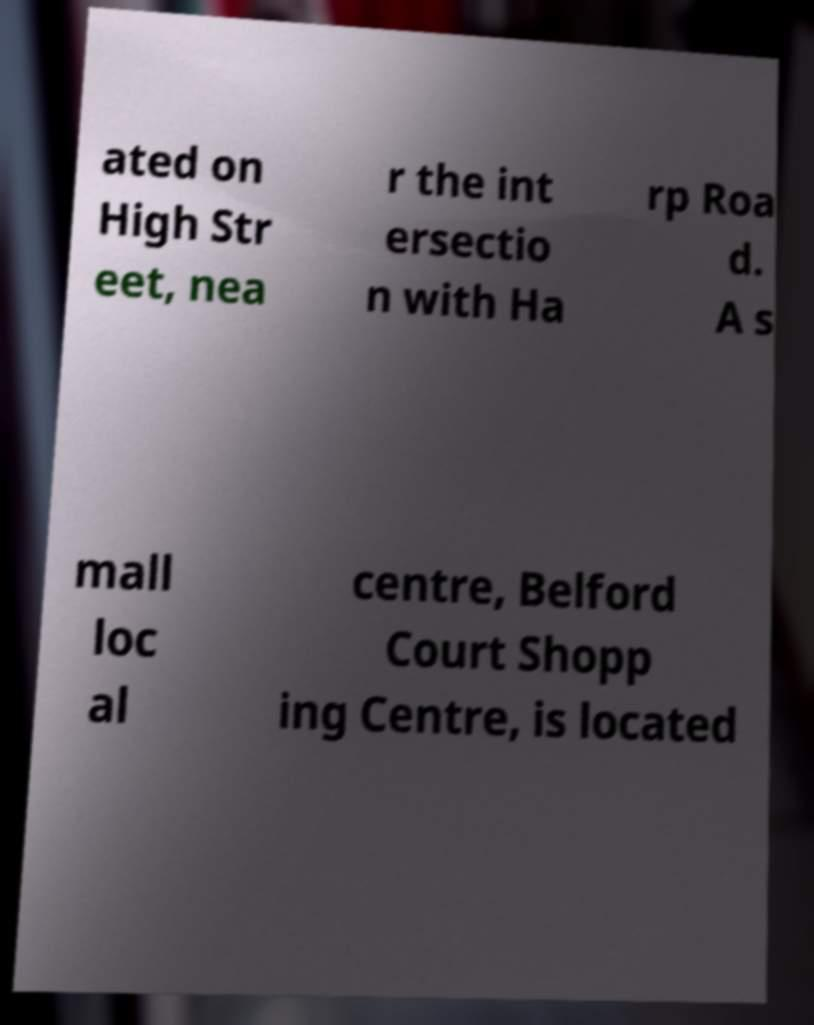Could you extract and type out the text from this image? ated on High Str eet, nea r the int ersectio n with Ha rp Roa d. A s mall loc al centre, Belford Court Shopp ing Centre, is located 